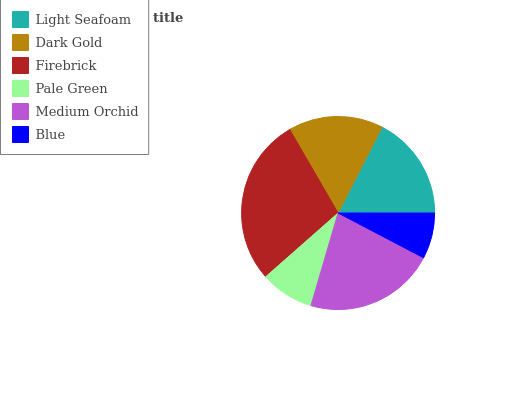Is Blue the minimum?
Answer yes or no. Yes. Is Firebrick the maximum?
Answer yes or no. Yes. Is Dark Gold the minimum?
Answer yes or no. No. Is Dark Gold the maximum?
Answer yes or no. No. Is Light Seafoam greater than Dark Gold?
Answer yes or no. Yes. Is Dark Gold less than Light Seafoam?
Answer yes or no. Yes. Is Dark Gold greater than Light Seafoam?
Answer yes or no. No. Is Light Seafoam less than Dark Gold?
Answer yes or no. No. Is Light Seafoam the high median?
Answer yes or no. Yes. Is Dark Gold the low median?
Answer yes or no. Yes. Is Blue the high median?
Answer yes or no. No. Is Firebrick the low median?
Answer yes or no. No. 